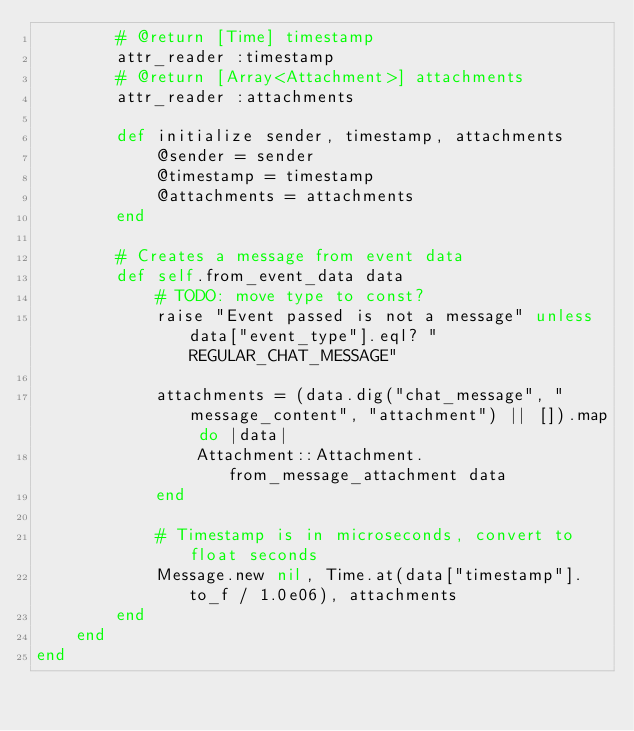<code> <loc_0><loc_0><loc_500><loc_500><_Ruby_>		# @return [Time] timestamp
		attr_reader :timestamp
		# @return [Array<Attachment>] attachments
		attr_reader :attachments

		def initialize sender, timestamp, attachments
			@sender = sender
			@timestamp = timestamp
			@attachments = attachments
		end

		# Creates a message from event data
		def self.from_event_data data
			# TODO: move type to const?
			raise "Event passed is not a message" unless data["event_type"].eql? "REGULAR_CHAT_MESSAGE"

			attachments = (data.dig("chat_message", "message_content", "attachment") || []).map do |data|
				Attachment::Attachment.from_message_attachment data
			end

			# Timestamp is in microseconds, convert to float seconds
			Message.new nil, Time.at(data["timestamp"].to_f / 1.0e06), attachments
		end
	end
end
</code> 